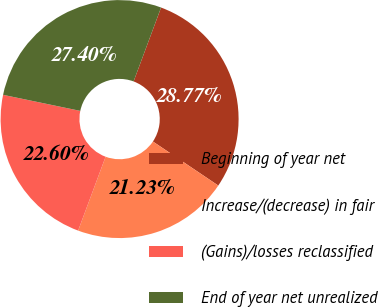<chart> <loc_0><loc_0><loc_500><loc_500><pie_chart><fcel>Beginning of year net<fcel>Increase/(decrease) in fair<fcel>(Gains)/losses reclassified<fcel>End of year net unrealized<nl><fcel>28.77%<fcel>21.23%<fcel>22.6%<fcel>27.4%<nl></chart> 